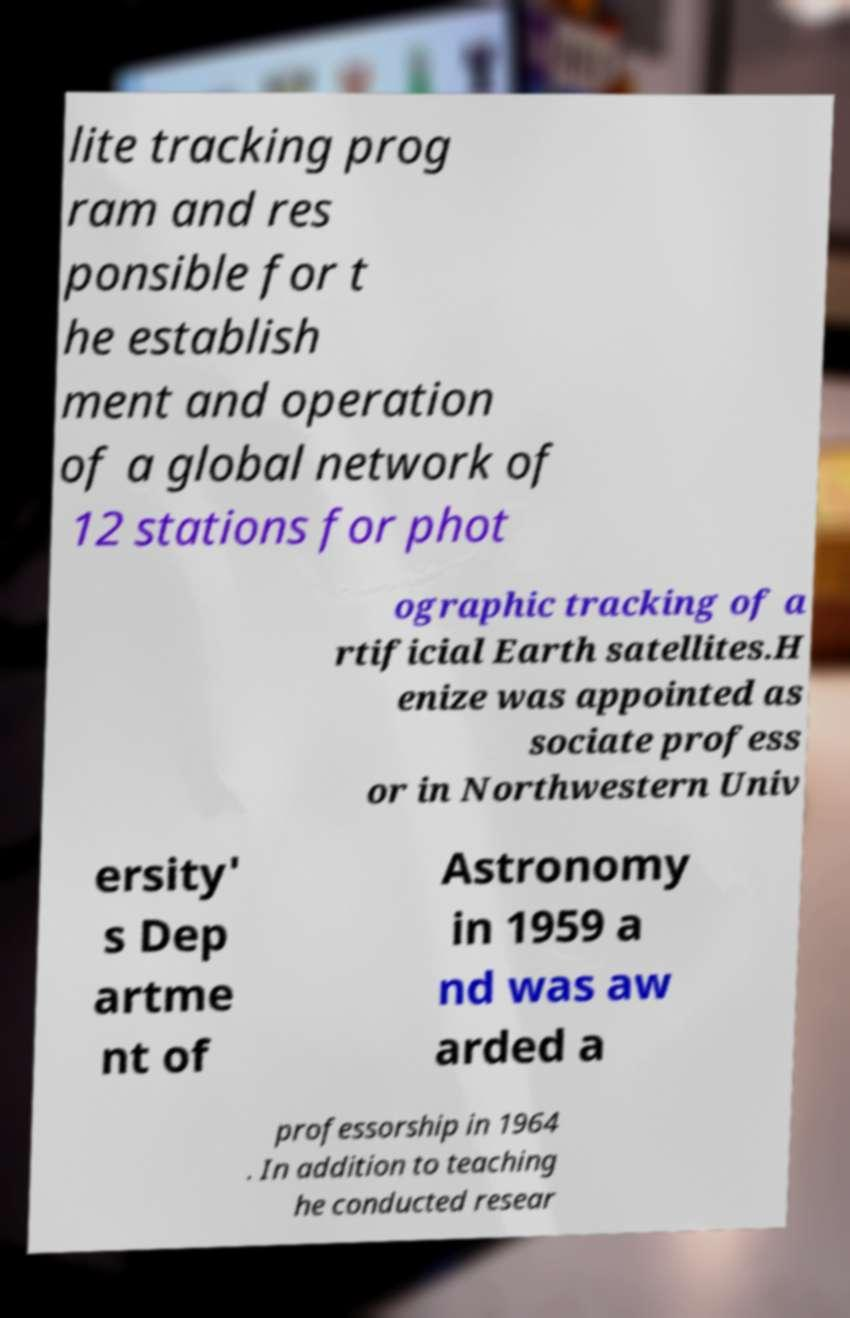Could you assist in decoding the text presented in this image and type it out clearly? lite tracking prog ram and res ponsible for t he establish ment and operation of a global network of 12 stations for phot ographic tracking of a rtificial Earth satellites.H enize was appointed as sociate profess or in Northwestern Univ ersity' s Dep artme nt of Astronomy in 1959 a nd was aw arded a professorship in 1964 . In addition to teaching he conducted resear 